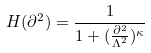Convert formula to latex. <formula><loc_0><loc_0><loc_500><loc_500>H ( \partial ^ { 2 } ) = \frac { 1 } { 1 + ( \frac { \partial ^ { 2 } } { \Lambda ^ { 2 } } ) ^ { \kappa } }</formula> 